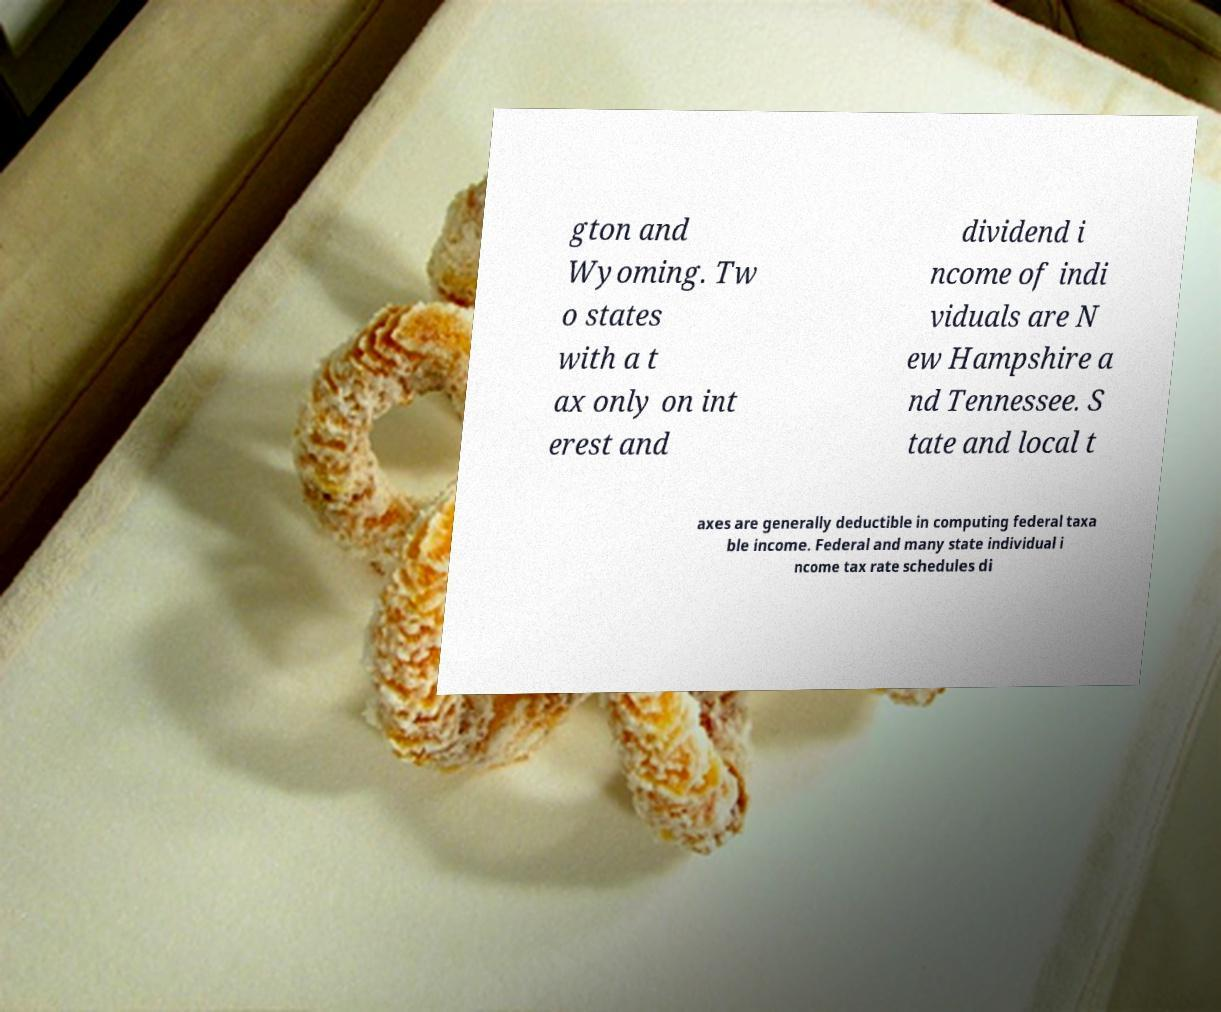For documentation purposes, I need the text within this image transcribed. Could you provide that? gton and Wyoming. Tw o states with a t ax only on int erest and dividend i ncome of indi viduals are N ew Hampshire a nd Tennessee. S tate and local t axes are generally deductible in computing federal taxa ble income. Federal and many state individual i ncome tax rate schedules di 